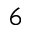<formula> <loc_0><loc_0><loc_500><loc_500>^ { 6 }</formula> 